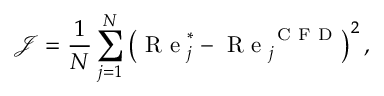Convert formula to latex. <formula><loc_0><loc_0><loc_500><loc_500>\mathcal { J } = \frac { 1 } { N } \sum _ { j = 1 } ^ { N } \left ( R e _ { j } ^ { \ast } - R e _ { j } ^ { C F D } \right ) ^ { 2 } ,</formula> 